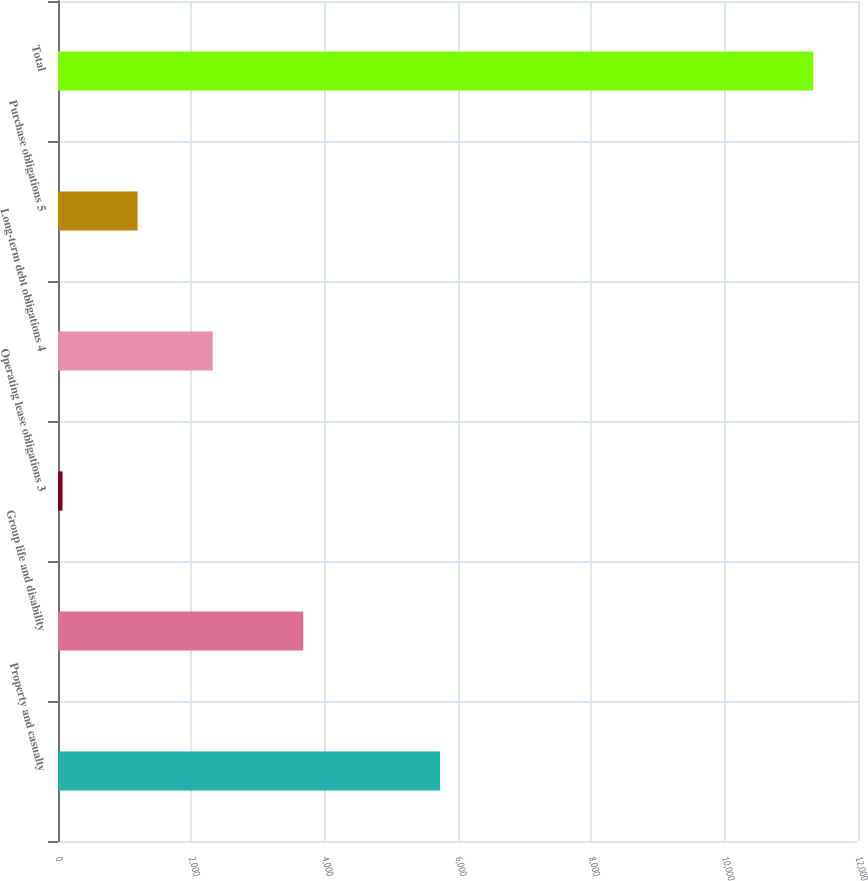<chart> <loc_0><loc_0><loc_500><loc_500><bar_chart><fcel>Property and casualty<fcel>Group life and disability<fcel>Operating lease obligations 3<fcel>Long-term debt obligations 4<fcel>Purchase obligations 5<fcel>Total<nl><fcel>5730<fcel>3679<fcel>68<fcel>2320<fcel>1194<fcel>11328<nl></chart> 